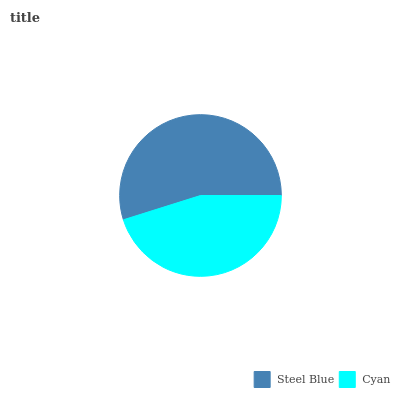Is Cyan the minimum?
Answer yes or no. Yes. Is Steel Blue the maximum?
Answer yes or no. Yes. Is Cyan the maximum?
Answer yes or no. No. Is Steel Blue greater than Cyan?
Answer yes or no. Yes. Is Cyan less than Steel Blue?
Answer yes or no. Yes. Is Cyan greater than Steel Blue?
Answer yes or no. No. Is Steel Blue less than Cyan?
Answer yes or no. No. Is Steel Blue the high median?
Answer yes or no. Yes. Is Cyan the low median?
Answer yes or no. Yes. Is Cyan the high median?
Answer yes or no. No. Is Steel Blue the low median?
Answer yes or no. No. 